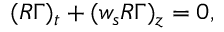Convert formula to latex. <formula><loc_0><loc_0><loc_500><loc_500>( R \Gamma ) _ { t } + ( w _ { s } R \Gamma ) _ { z } = 0 ,</formula> 